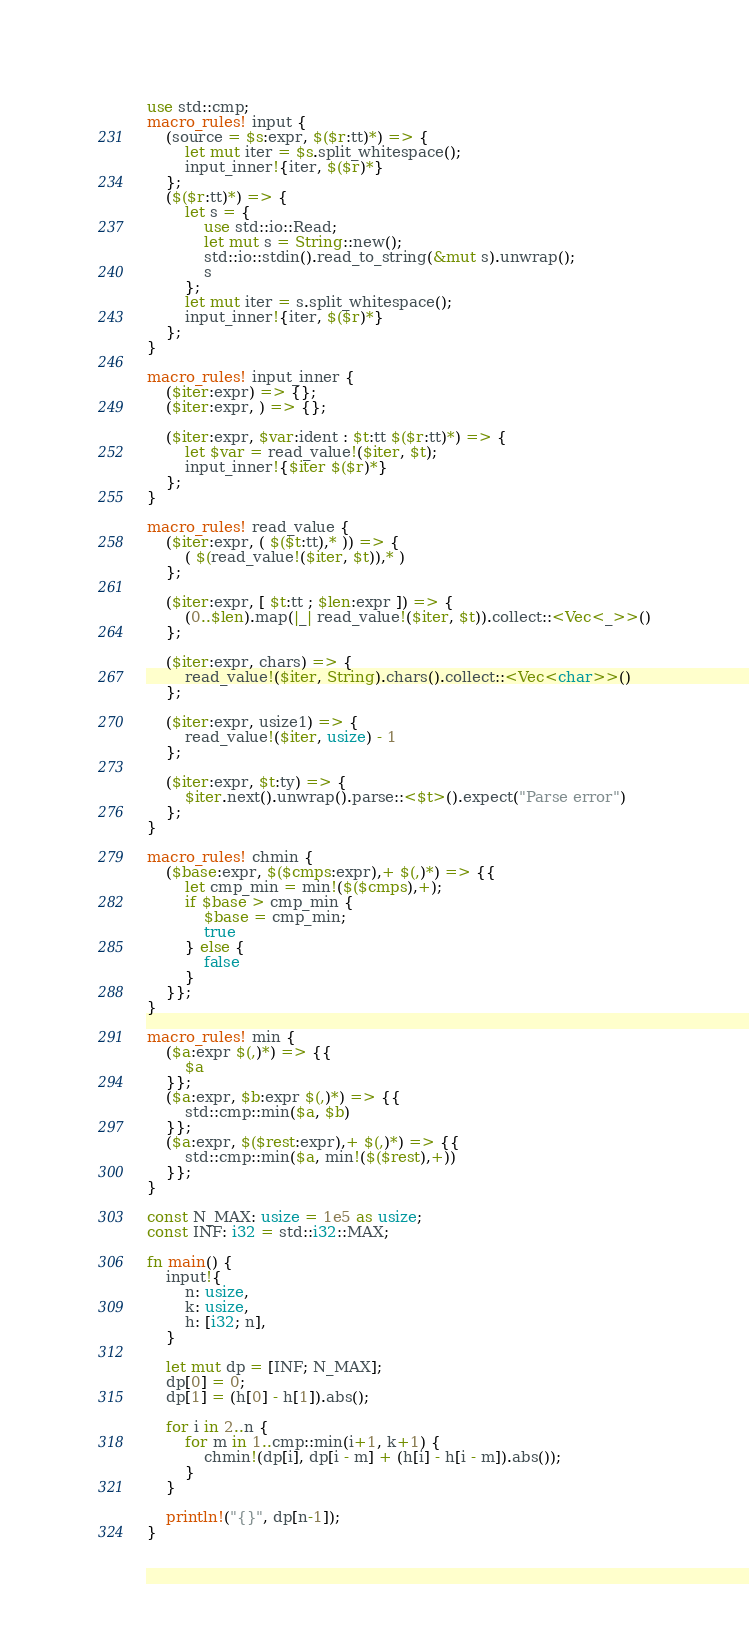<code> <loc_0><loc_0><loc_500><loc_500><_Rust_>use std::cmp;
macro_rules! input {
    (source = $s:expr, $($r:tt)*) => {
        let mut iter = $s.split_whitespace();
        input_inner!{iter, $($r)*}
    };
    ($($r:tt)*) => {
        let s = {
            use std::io::Read;
            let mut s = String::new();
            std::io::stdin().read_to_string(&mut s).unwrap();
            s
        };
        let mut iter = s.split_whitespace();
        input_inner!{iter, $($r)*}
    };
}

macro_rules! input_inner {
    ($iter:expr) => {};
    ($iter:expr, ) => {};

    ($iter:expr, $var:ident : $t:tt $($r:tt)*) => {
        let $var = read_value!($iter, $t);
        input_inner!{$iter $($r)*}
    };
}

macro_rules! read_value {
    ($iter:expr, ( $($t:tt),* )) => {
        ( $(read_value!($iter, $t)),* )
    };

    ($iter:expr, [ $t:tt ; $len:expr ]) => {
        (0..$len).map(|_| read_value!($iter, $t)).collect::<Vec<_>>()
    };

    ($iter:expr, chars) => {
        read_value!($iter, String).chars().collect::<Vec<char>>()
    };

    ($iter:expr, usize1) => {
        read_value!($iter, usize) - 1
    };

    ($iter:expr, $t:ty) => {
        $iter.next().unwrap().parse::<$t>().expect("Parse error")
    };
}

macro_rules! chmin {
    ($base:expr, $($cmps:expr),+ $(,)*) => {{
        let cmp_min = min!($($cmps),+);
        if $base > cmp_min {
            $base = cmp_min;
            true
        } else {
            false
        }
    }};
}

macro_rules! min {
    ($a:expr $(,)*) => {{
        $a
    }};
    ($a:expr, $b:expr $(,)*) => {{
        std::cmp::min($a, $b)
    }};
    ($a:expr, $($rest:expr),+ $(,)*) => {{
        std::cmp::min($a, min!($($rest),+))
    }};
}

const N_MAX: usize = 1e5 as usize;
const INF: i32 = std::i32::MAX;

fn main() {
    input!{
        n: usize,
        k: usize,
        h: [i32; n],
    }

    let mut dp = [INF; N_MAX];
    dp[0] = 0;
    dp[1] = (h[0] - h[1]).abs();

    for i in 2..n {
        for m in 1..cmp::min(i+1, k+1) {
            chmin!(dp[i], dp[i - m] + (h[i] - h[i - m]).abs());
        }
    }

    println!("{}", dp[n-1]);
}
</code> 